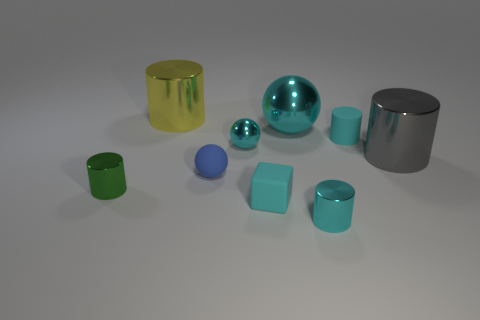There is a sphere that is in front of the gray cylinder that is behind the green shiny thing; is there a big gray metal cylinder that is behind it?
Ensure brevity in your answer.  Yes. There is a big gray object that is made of the same material as the small green thing; what shape is it?
Give a very brief answer. Cylinder. Are there more big green cubes than cyan matte cylinders?
Offer a very short reply. No. Is the shape of the yellow object the same as the tiny cyan matte object to the right of the matte cube?
Ensure brevity in your answer.  Yes. What material is the cube?
Provide a succinct answer. Rubber. There is a big metal cylinder in front of the cyan sphere that is in front of the cyan matte thing that is behind the cyan block; what is its color?
Ensure brevity in your answer.  Gray. What is the material of the blue object that is the same shape as the big cyan metal thing?
Keep it short and to the point. Rubber. How many blue things are the same size as the gray metallic cylinder?
Give a very brief answer. 0. How many cyan objects are there?
Provide a short and direct response. 5. Is the material of the gray thing the same as the block on the left side of the large shiny sphere?
Offer a very short reply. No. 